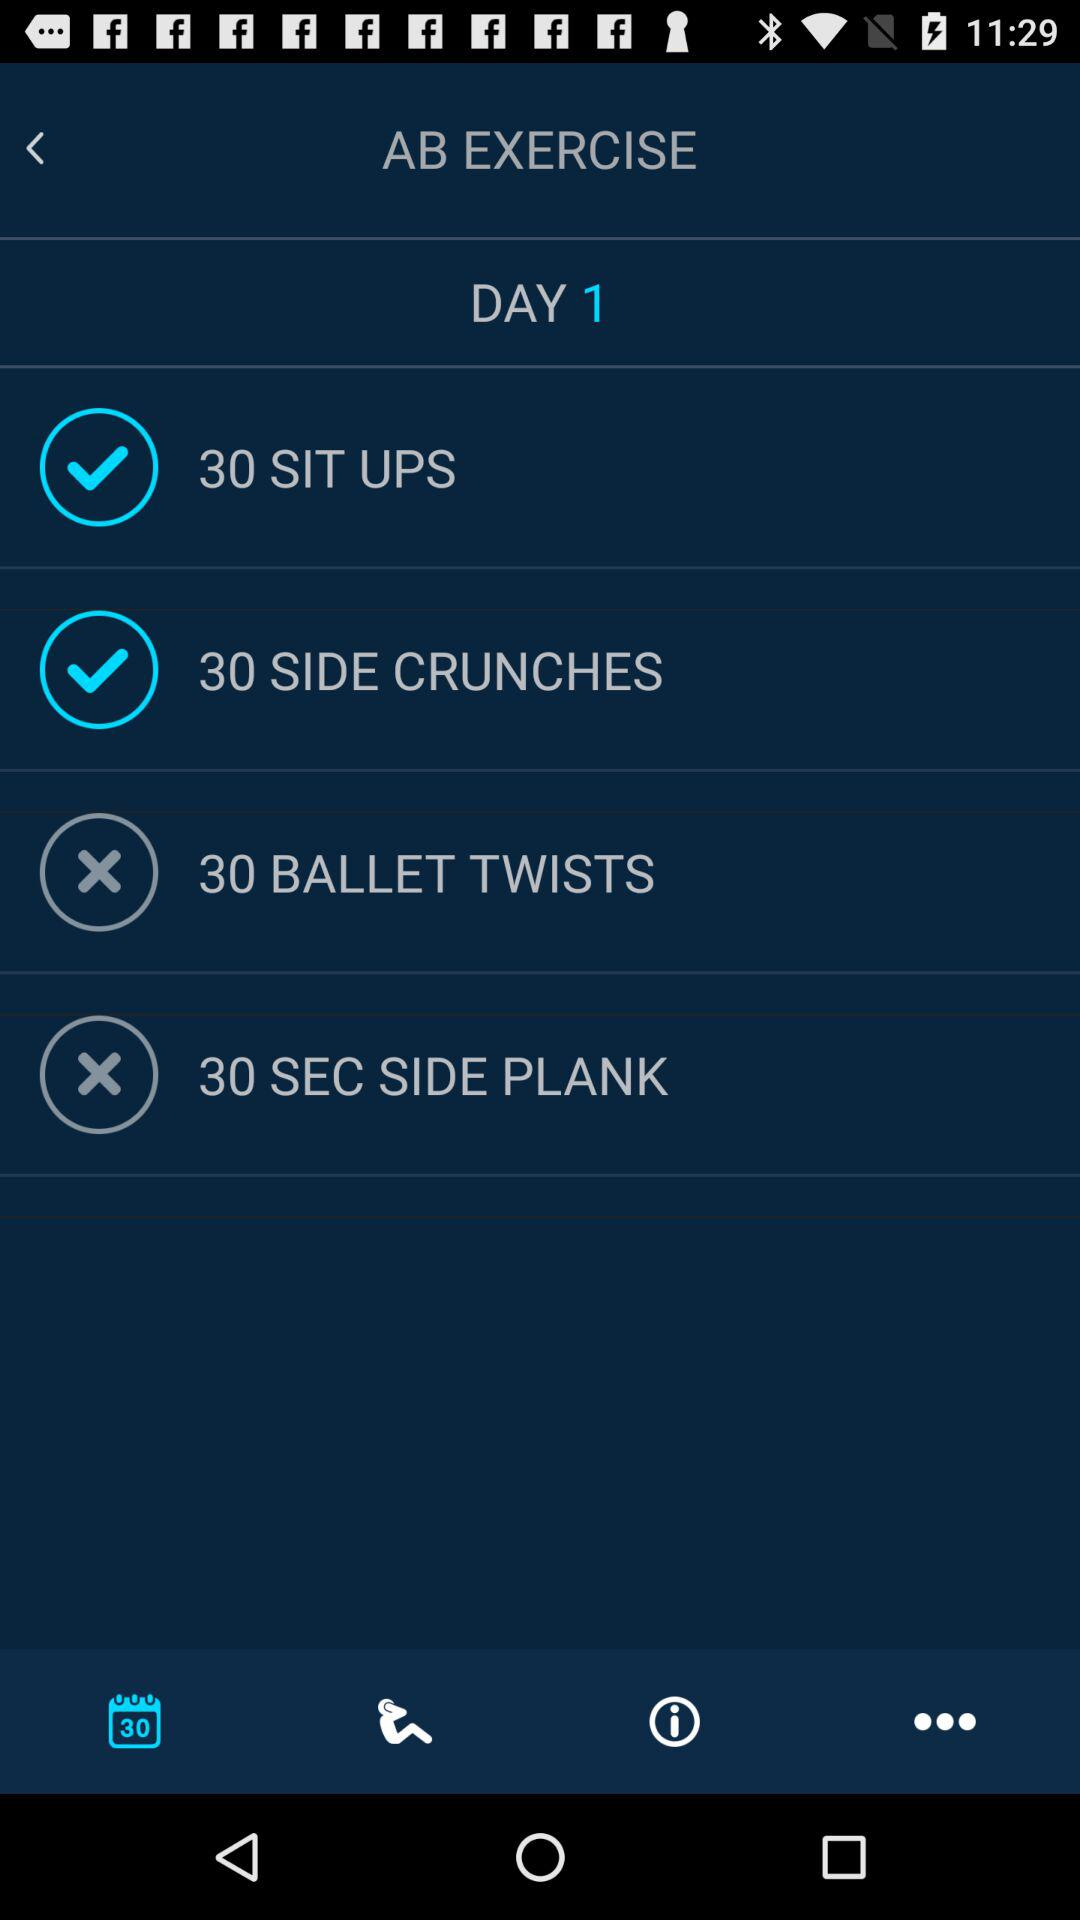How many exercises have not been completed?
Answer the question using a single word or phrase. 2 